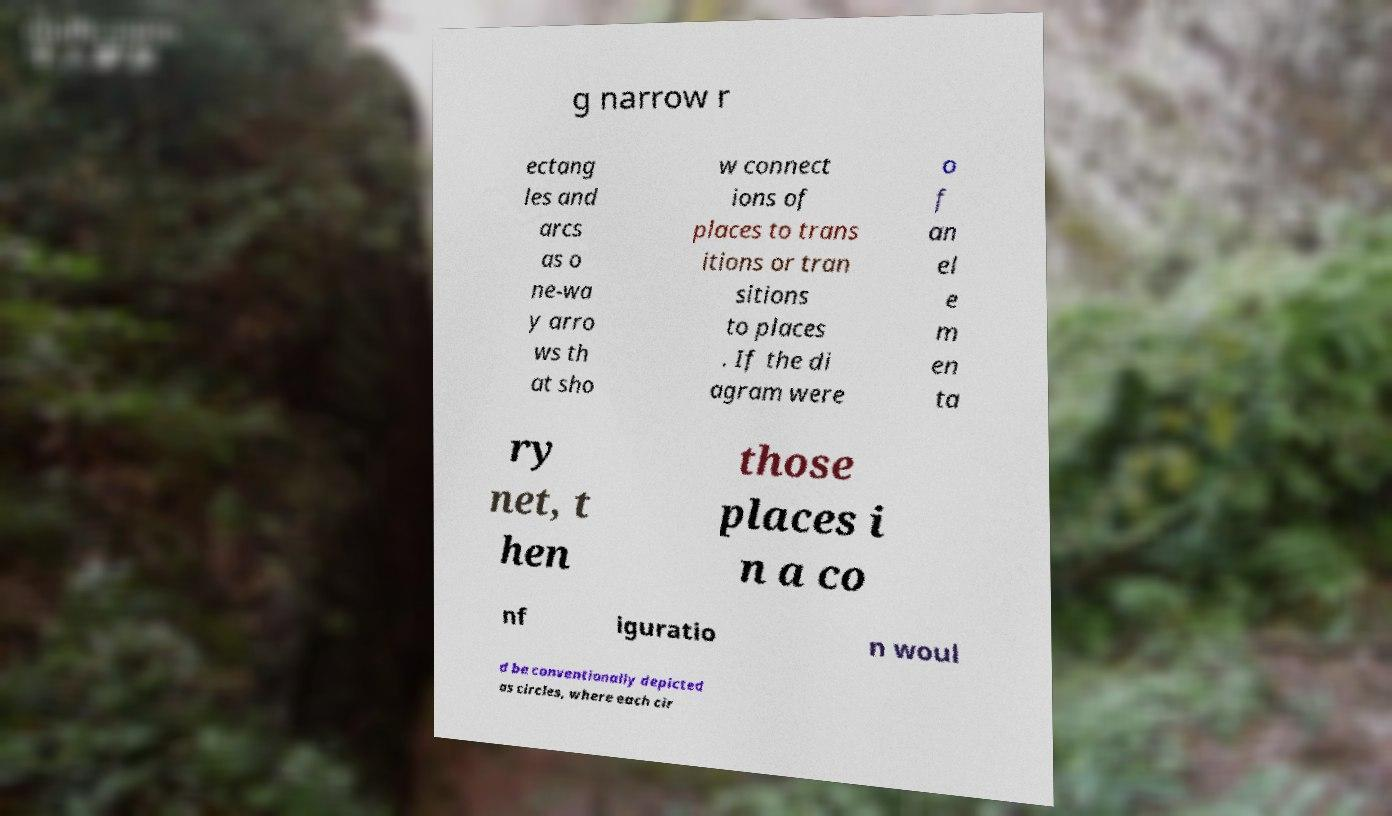There's text embedded in this image that I need extracted. Can you transcribe it verbatim? g narrow r ectang les and arcs as o ne-wa y arro ws th at sho w connect ions of places to trans itions or tran sitions to places . If the di agram were o f an el e m en ta ry net, t hen those places i n a co nf iguratio n woul d be conventionally depicted as circles, where each cir 